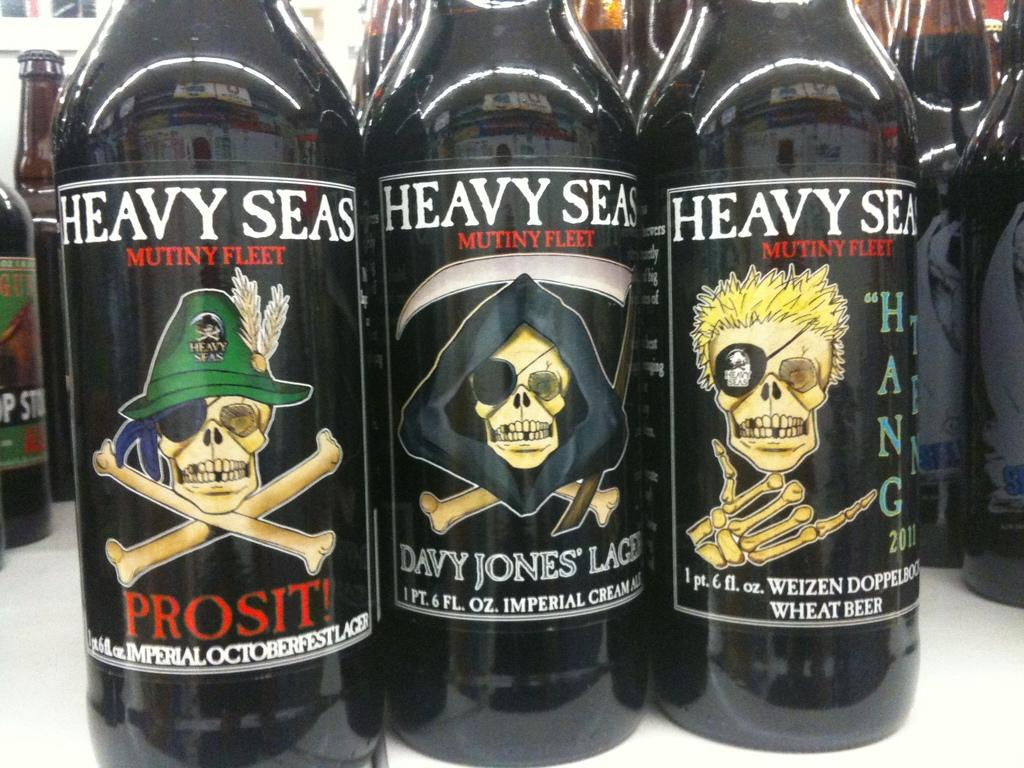<image>
Render a clear and concise summary of the photo. Three black Heavy Seas beer bottles placed next to each other. 